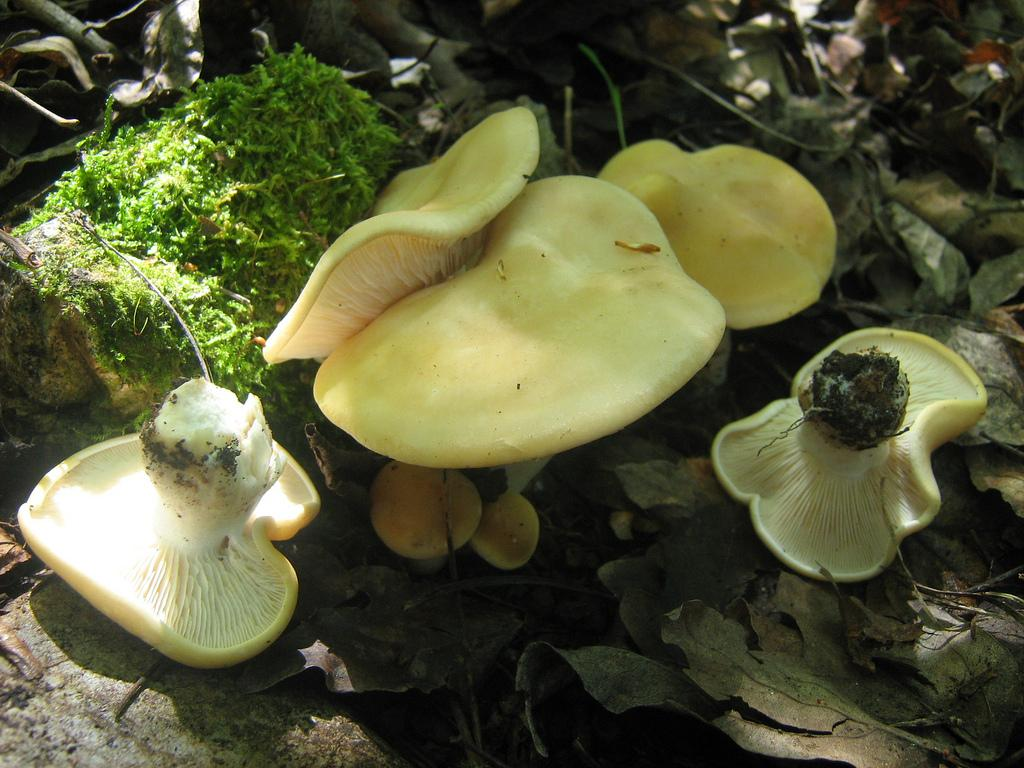What type of fungi can be seen in the image? There are mushrooms in the image. What type of plant material is present in the image? There are dried leaves in the image. What other type of plant can be seen in the image? There is a plant in the image. What type of war is depicted in the image? There is no war depicted in the image; it features mushrooms, dried leaves, and a plant. Can you tell me how many chess pieces are visible in the image? There are no chess pieces present in the image. 